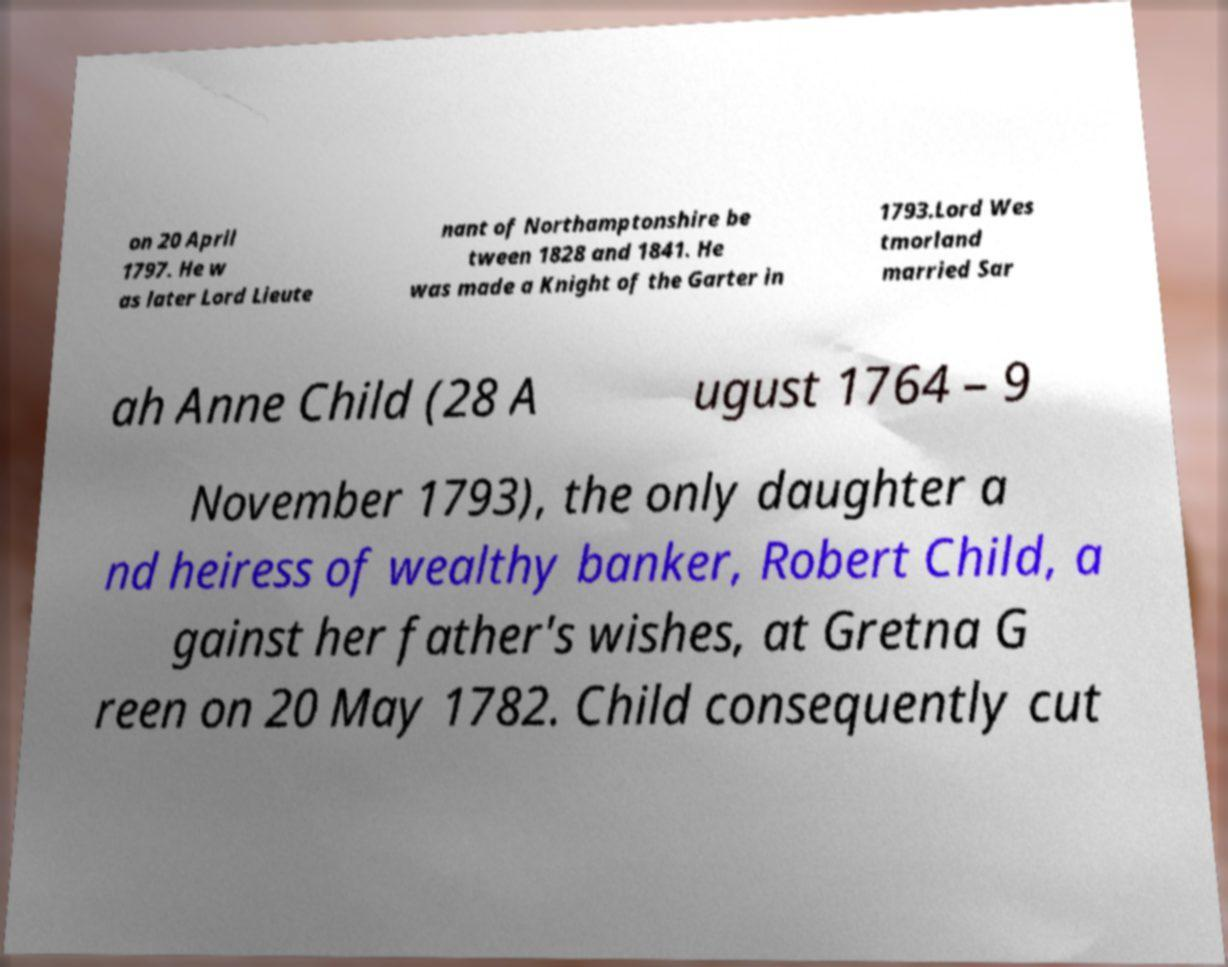I need the written content from this picture converted into text. Can you do that? on 20 April 1797. He w as later Lord Lieute nant of Northamptonshire be tween 1828 and 1841. He was made a Knight of the Garter in 1793.Lord Wes tmorland married Sar ah Anne Child (28 A ugust 1764 – 9 November 1793), the only daughter a nd heiress of wealthy banker, Robert Child, a gainst her father's wishes, at Gretna G reen on 20 May 1782. Child consequently cut 